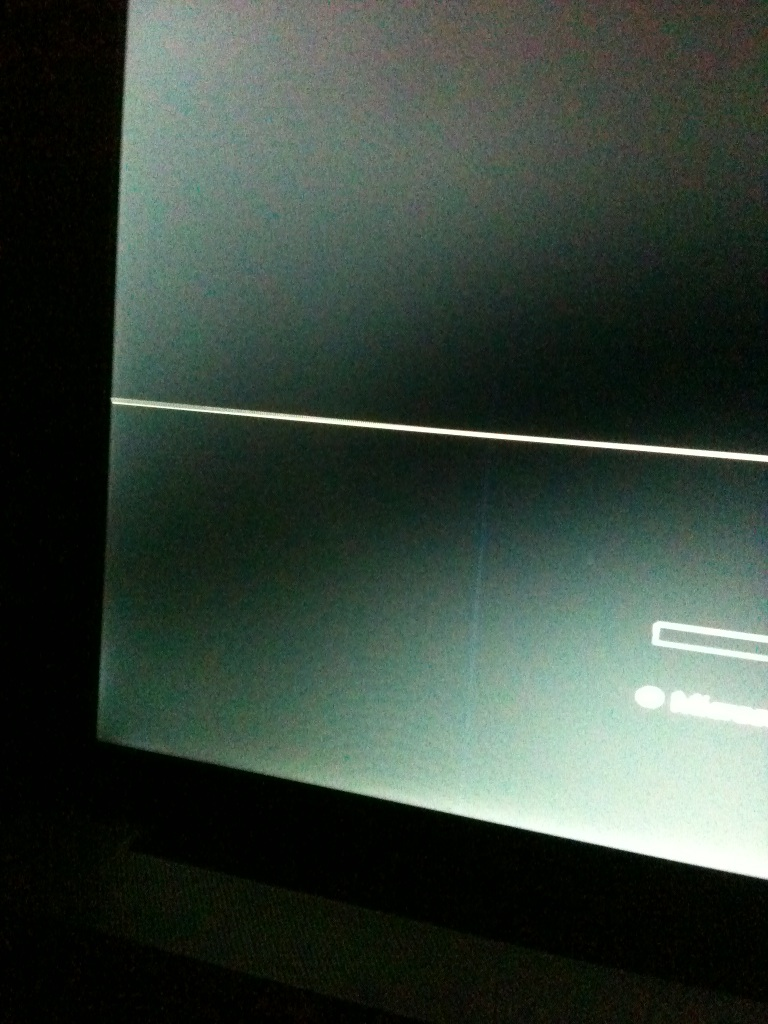What's on the screen? The image quality is quite low, making it difficult to discern specific details on the screen clearly. There appears to be a faint graphical line across the middle suggesting some kind of division or design, and a textbox visible at the bottom, hinting at possible text input or a dialogue box function, although the exact contents cannot be confidently stated. 